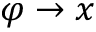<formula> <loc_0><loc_0><loc_500><loc_500>\varphi \rightarrow x</formula> 